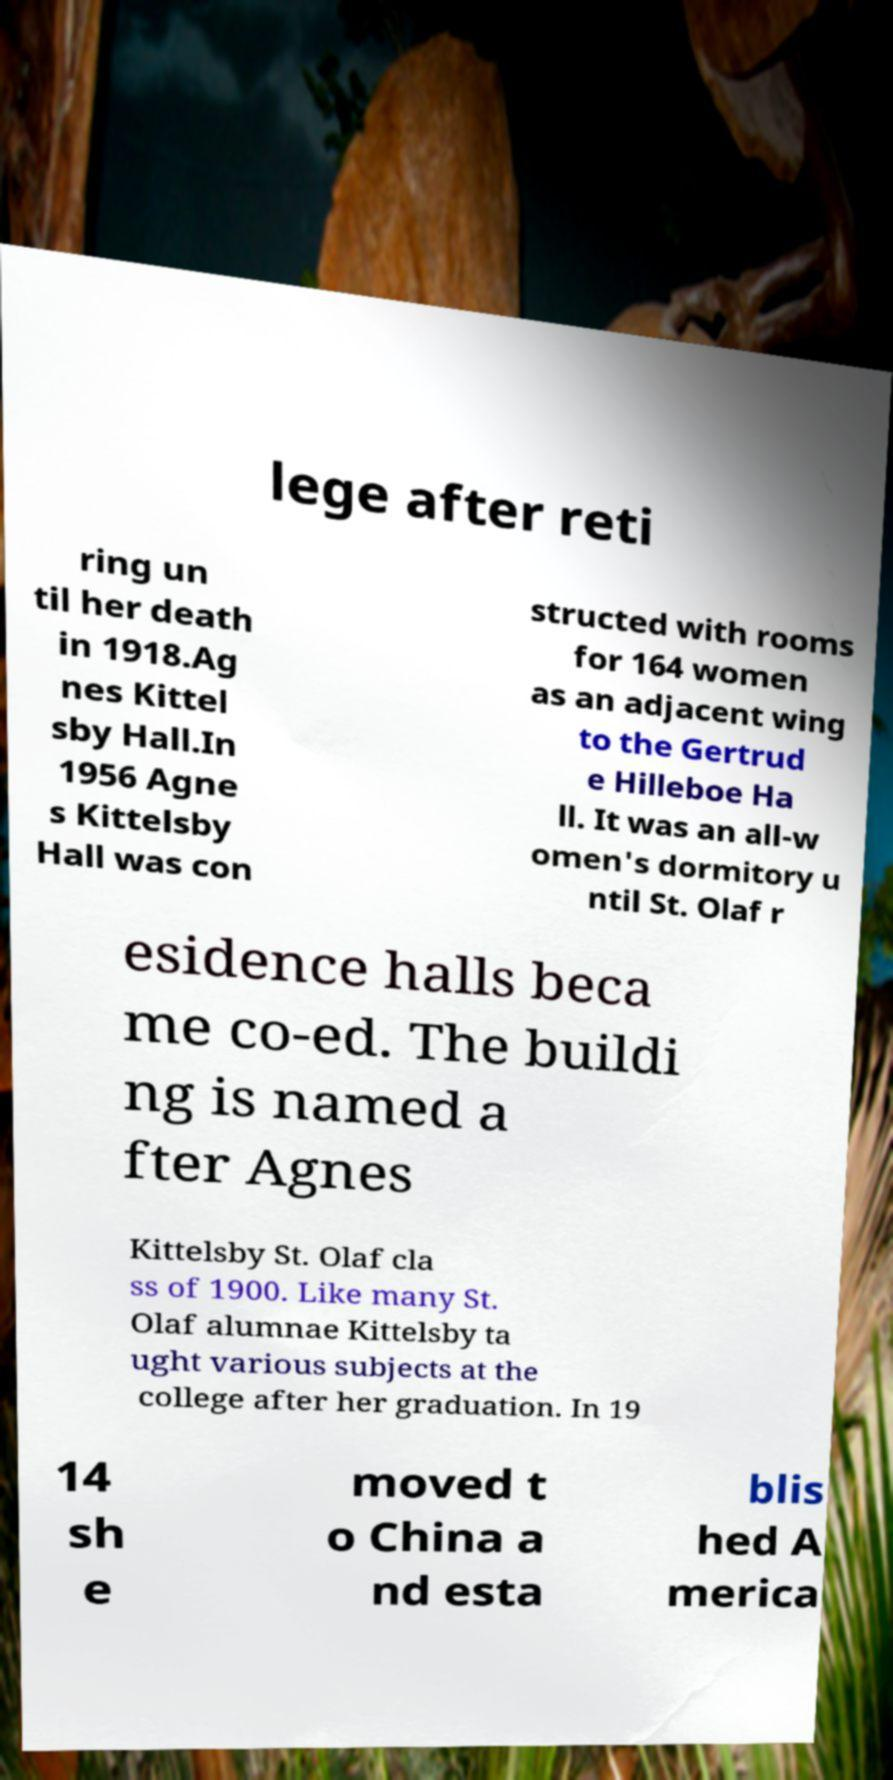Please read and relay the text visible in this image. What does it say? lege after reti ring un til her death in 1918.Ag nes Kittel sby Hall.In 1956 Agne s Kittelsby Hall was con structed with rooms for 164 women as an adjacent wing to the Gertrud e Hilleboe Ha ll. It was an all-w omen's dormitory u ntil St. Olaf r esidence halls beca me co-ed. The buildi ng is named a fter Agnes Kittelsby St. Olaf cla ss of 1900. Like many St. Olaf alumnae Kittelsby ta ught various subjects at the college after her graduation. In 19 14 sh e moved t o China a nd esta blis hed A merica 